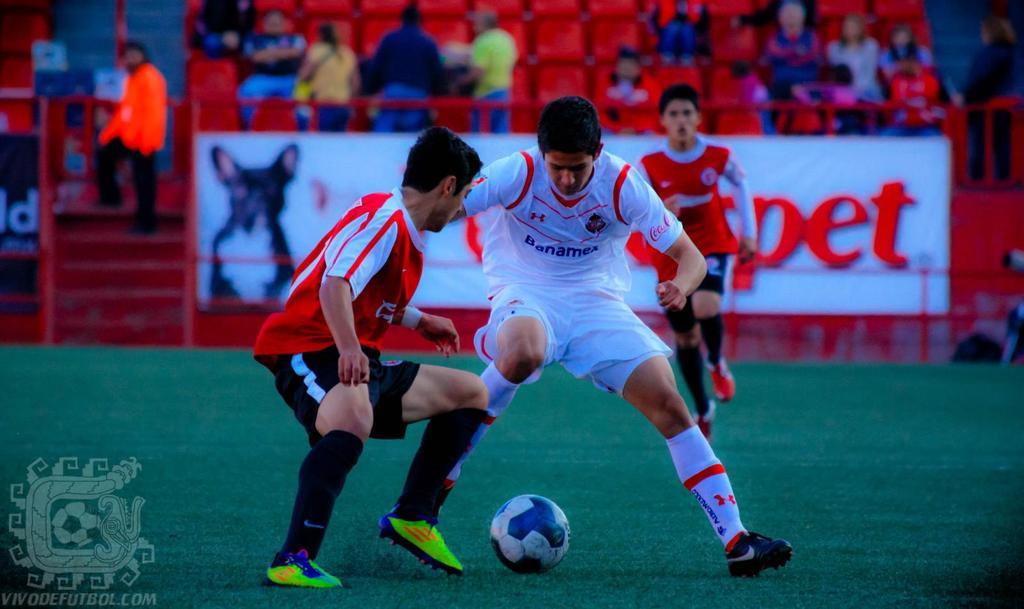What is the name on the front of the white shirt?
Offer a terse response. Banamex. What brand showing on the white shirt?
Your answer should be very brief. Banamex. 